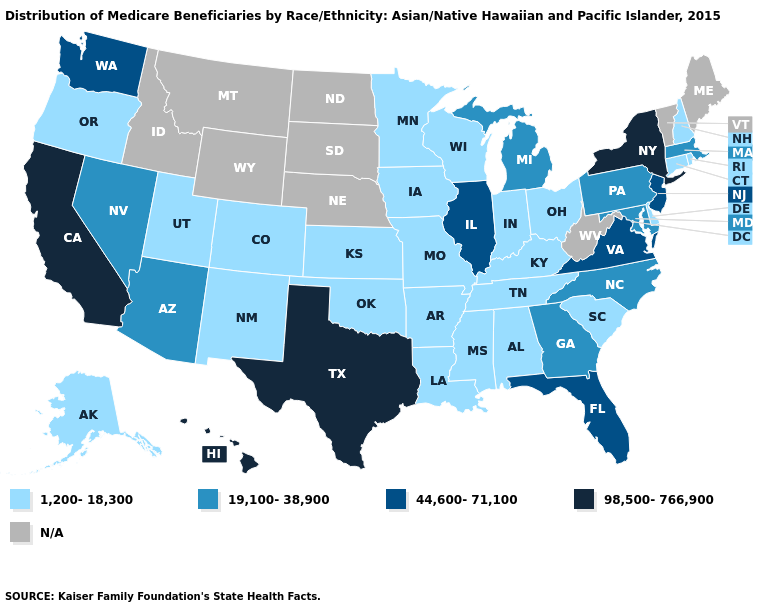Among the states that border Kentucky , does Tennessee have the highest value?
Concise answer only. No. Name the states that have a value in the range 44,600-71,100?
Be succinct. Florida, Illinois, New Jersey, Virginia, Washington. What is the highest value in the West ?
Be succinct. 98,500-766,900. What is the value of New Mexico?
Be succinct. 1,200-18,300. Is the legend a continuous bar?
Give a very brief answer. No. Name the states that have a value in the range 1,200-18,300?
Write a very short answer. Alabama, Alaska, Arkansas, Colorado, Connecticut, Delaware, Indiana, Iowa, Kansas, Kentucky, Louisiana, Minnesota, Mississippi, Missouri, New Hampshire, New Mexico, Ohio, Oklahoma, Oregon, Rhode Island, South Carolina, Tennessee, Utah, Wisconsin. What is the value of North Carolina?
Quick response, please. 19,100-38,900. What is the value of Georgia?
Answer briefly. 19,100-38,900. Name the states that have a value in the range N/A?
Answer briefly. Idaho, Maine, Montana, Nebraska, North Dakota, South Dakota, Vermont, West Virginia, Wyoming. Does the map have missing data?
Give a very brief answer. Yes. What is the highest value in the USA?
Give a very brief answer. 98,500-766,900. Name the states that have a value in the range N/A?
Short answer required. Idaho, Maine, Montana, Nebraska, North Dakota, South Dakota, Vermont, West Virginia, Wyoming. How many symbols are there in the legend?
Answer briefly. 5. How many symbols are there in the legend?
Give a very brief answer. 5. 